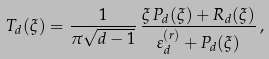<formula> <loc_0><loc_0><loc_500><loc_500>T _ { d } ( \xi ) = \frac { 1 } { \pi \sqrt { d - 1 } } \, \frac { \xi \, P _ { d } ( \xi ) + R _ { d } ( \xi ) } { \varepsilon _ { d } ^ { ( r ) } + P _ { d } ( \xi ) } \, ,</formula> 